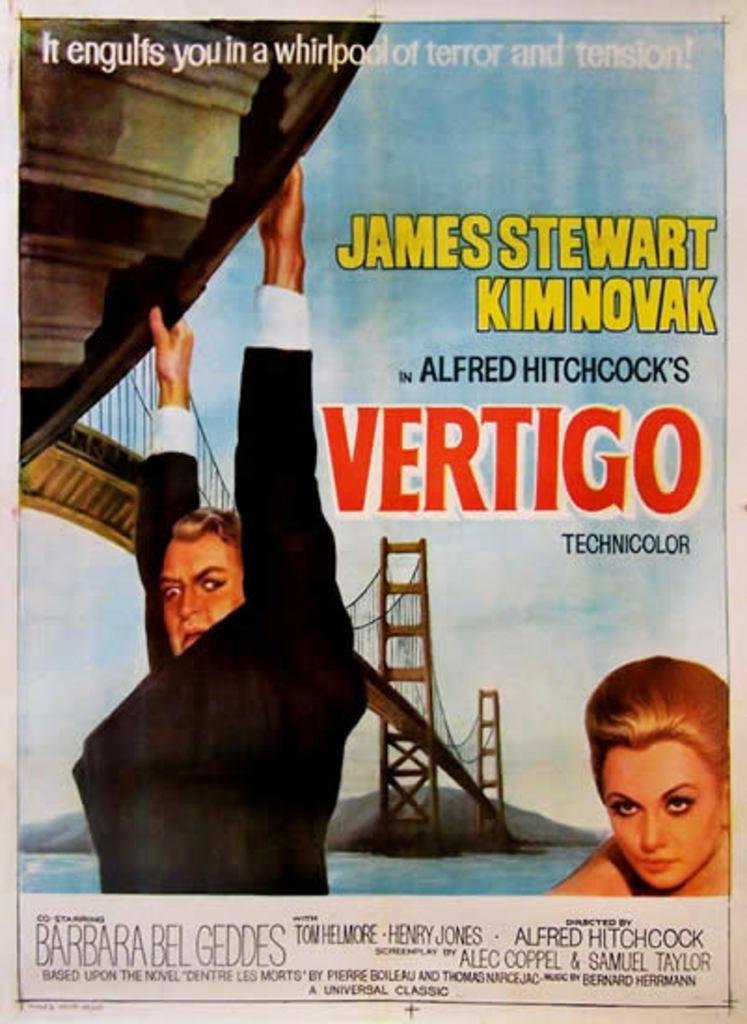<image>
Offer a succinct explanation of the picture presented. Poster showing a man hanging off a cliff with the word Vertigo next to him. 